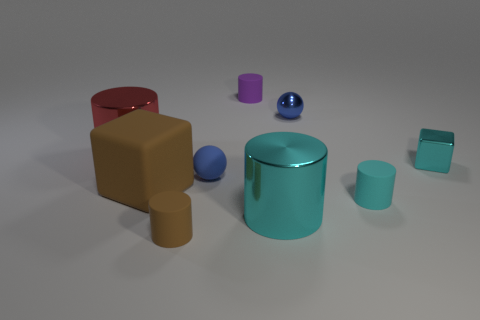Subtract all purple cylinders. How many cylinders are left? 4 Subtract all tiny cyan cylinders. How many cylinders are left? 4 Subtract all red balls. Subtract all cyan cylinders. How many balls are left? 2 Subtract all cubes. How many objects are left? 7 Add 1 large yellow rubber cubes. How many large yellow rubber cubes exist? 1 Subtract 0 red spheres. How many objects are left? 9 Subtract all tiny brown metallic cylinders. Subtract all cyan shiny things. How many objects are left? 7 Add 5 big red cylinders. How many big red cylinders are left? 6 